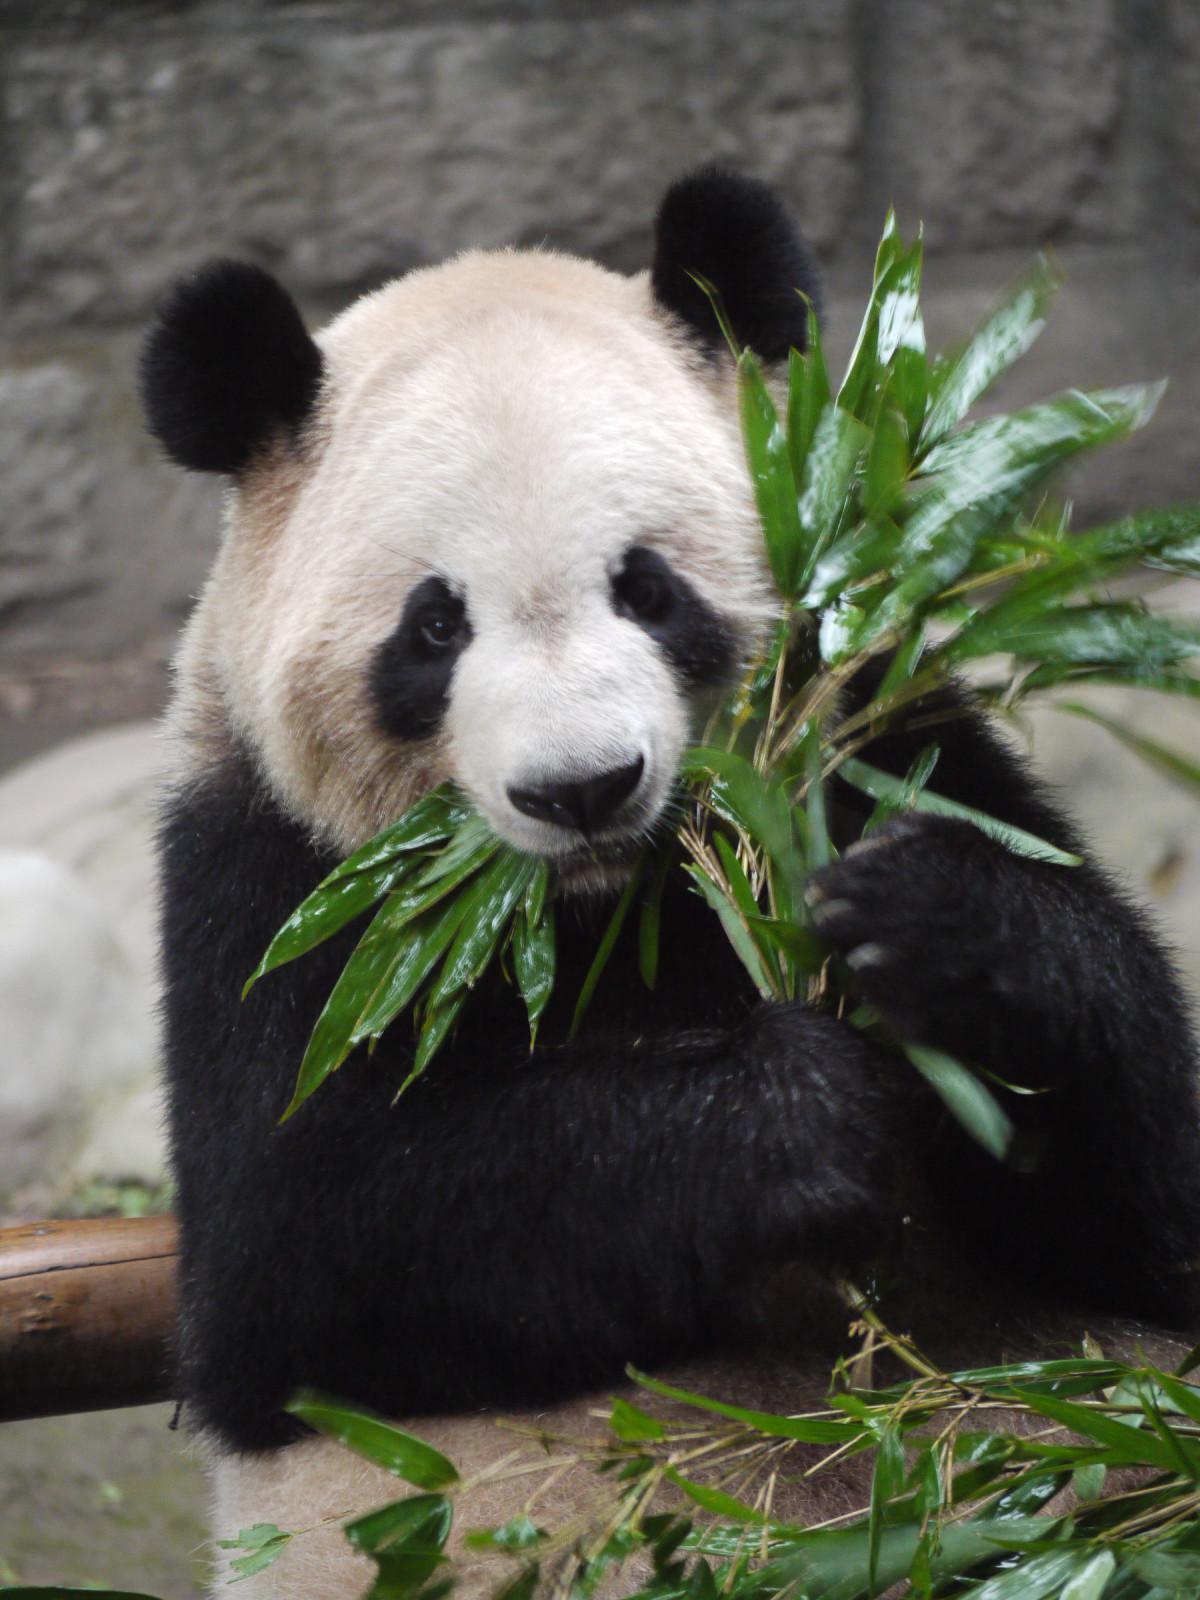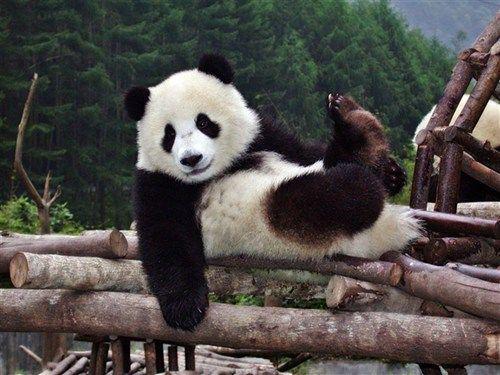The first image is the image on the left, the second image is the image on the right. Examine the images to the left and right. Is the description "A panda is eating in one of the images." accurate? Answer yes or no. Yes. The first image is the image on the left, the second image is the image on the right. Considering the images on both sides, is "In one of the images, a panda is eating something" valid? Answer yes or no. Yes. The first image is the image on the left, the second image is the image on the right. Analyze the images presented: Is the assertion "In one of the images, a panda has food in its mouth" valid? Answer yes or no. Yes. 